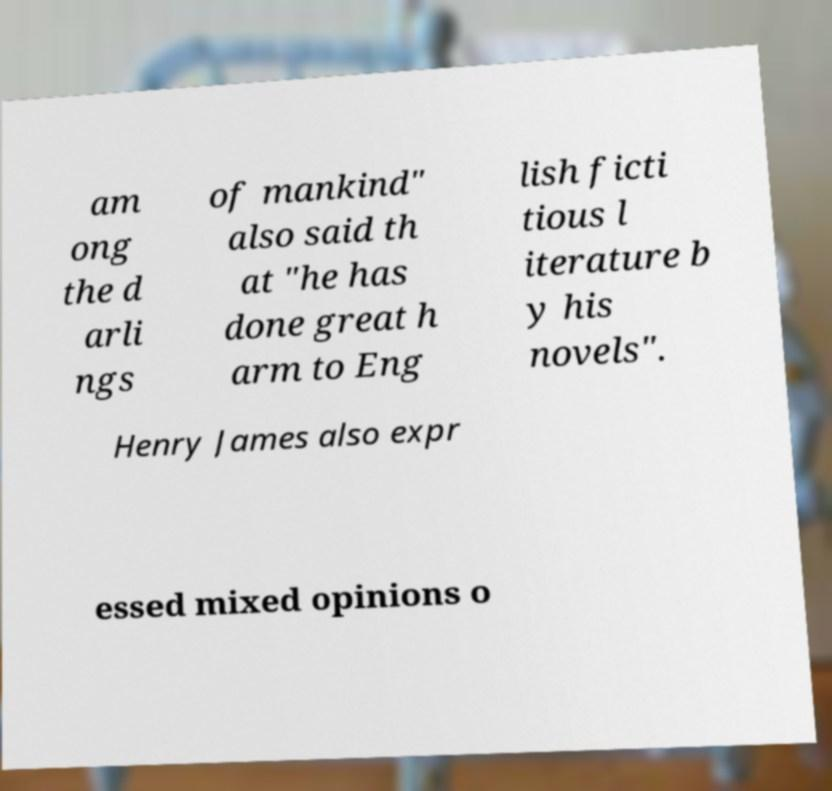There's text embedded in this image that I need extracted. Can you transcribe it verbatim? am ong the d arli ngs of mankind" also said th at "he has done great h arm to Eng lish ficti tious l iterature b y his novels". Henry James also expr essed mixed opinions o 